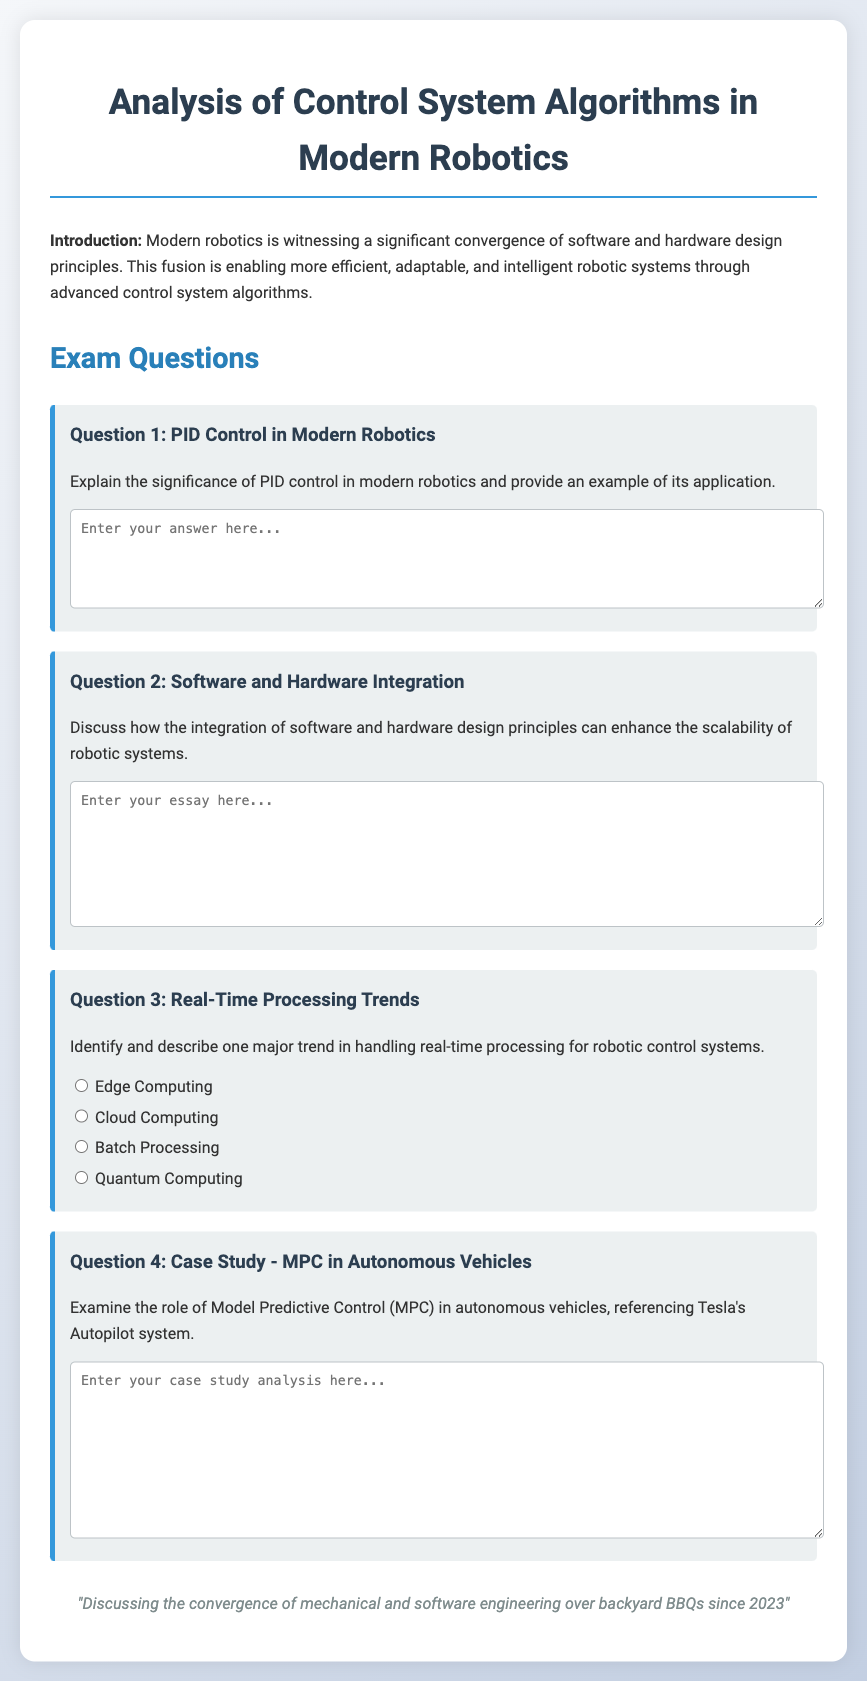What is the title of the exam? The title of the exam is mentioned at the top as "Analysis of Control System Algorithms in Modern Robotics."
Answer: Analysis of Control System Algorithms in Modern Robotics What is the significance of PID control in robotics? The document states to explain the significance of PID control in modern robotics, indicating it's important for the exam.
Answer: Importance in robotics What is one major trend in handling real-time processing? The document lists options for this question, indicating multiple potential answers.
Answer: Edge Computing What does MPC stand for in the context of autonomous vehicles? The question asks about the role of Model Predictive Control, referring to the acronym in the case study.
Answer: Model Predictive Control How many questions are presented in the exam? The main section of the document lists four distinct questions under "Exam Questions."
Answer: Four 